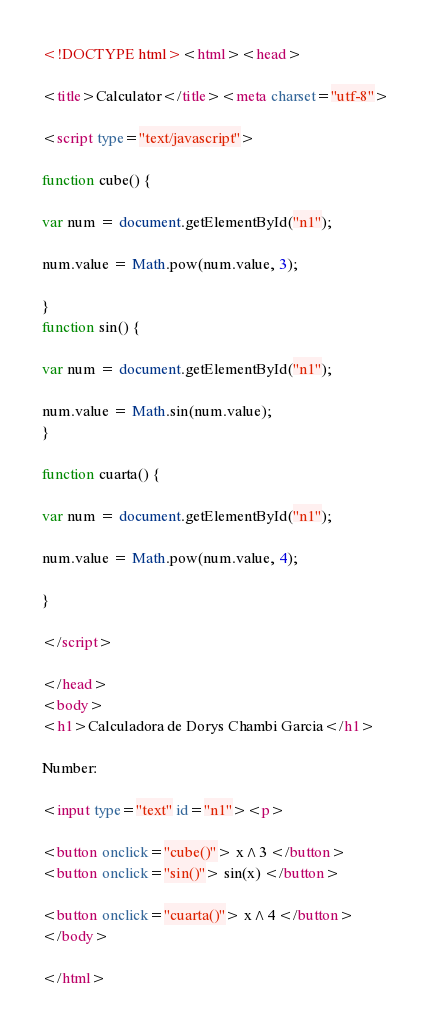<code> <loc_0><loc_0><loc_500><loc_500><_HTML_>
<!DOCTYPE html><html><head>

<title>Calculator</title><meta charset="utf-8">

<script type="text/javascript">

function cube() {

var num = document.getElementById("n1");

num.value = Math.pow(num.value, 3);

}
function sin() {

var num = document.getElementById("n1");

num.value = Math.sin(num.value);
}

function cuarta() {

var num = document.getElementById("n1");

num.value = Math.pow(num.value, 4);

}

</script>

</head>
<body>
<h1>Calculadora de Dorys Chambi Garcia</h1>

Number:

<input type="text" id="n1"><p>

<button onclick="cube()"> x^3 </button>
<button onclick="sin()"> sin(x) </button>

<button onclick="cuarta()"> x^4 </button>
</body>

</html></code> 